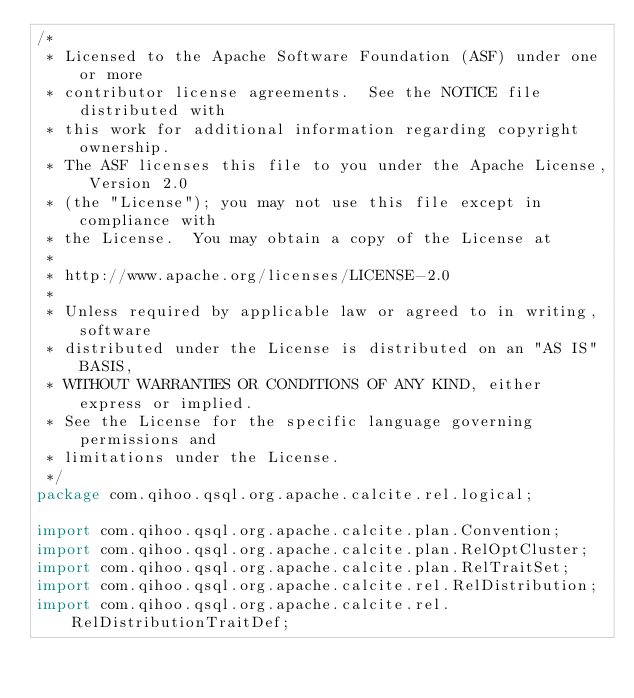Convert code to text. <code><loc_0><loc_0><loc_500><loc_500><_Java_>/*
 * Licensed to the Apache Software Foundation (ASF) under one or more
 * contributor license agreements.  See the NOTICE file distributed with
 * this work for additional information regarding copyright ownership.
 * The ASF licenses this file to you under the Apache License, Version 2.0
 * (the "License"); you may not use this file except in compliance with
 * the License.  You may obtain a copy of the License at
 *
 * http://www.apache.org/licenses/LICENSE-2.0
 *
 * Unless required by applicable law or agreed to in writing, software
 * distributed under the License is distributed on an "AS IS" BASIS,
 * WITHOUT WARRANTIES OR CONDITIONS OF ANY KIND, either express or implied.
 * See the License for the specific language governing permissions and
 * limitations under the License.
 */
package com.qihoo.qsql.org.apache.calcite.rel.logical;

import com.qihoo.qsql.org.apache.calcite.plan.Convention;
import com.qihoo.qsql.org.apache.calcite.plan.RelOptCluster;
import com.qihoo.qsql.org.apache.calcite.plan.RelTraitSet;
import com.qihoo.qsql.org.apache.calcite.rel.RelDistribution;
import com.qihoo.qsql.org.apache.calcite.rel.RelDistributionTraitDef;</code> 